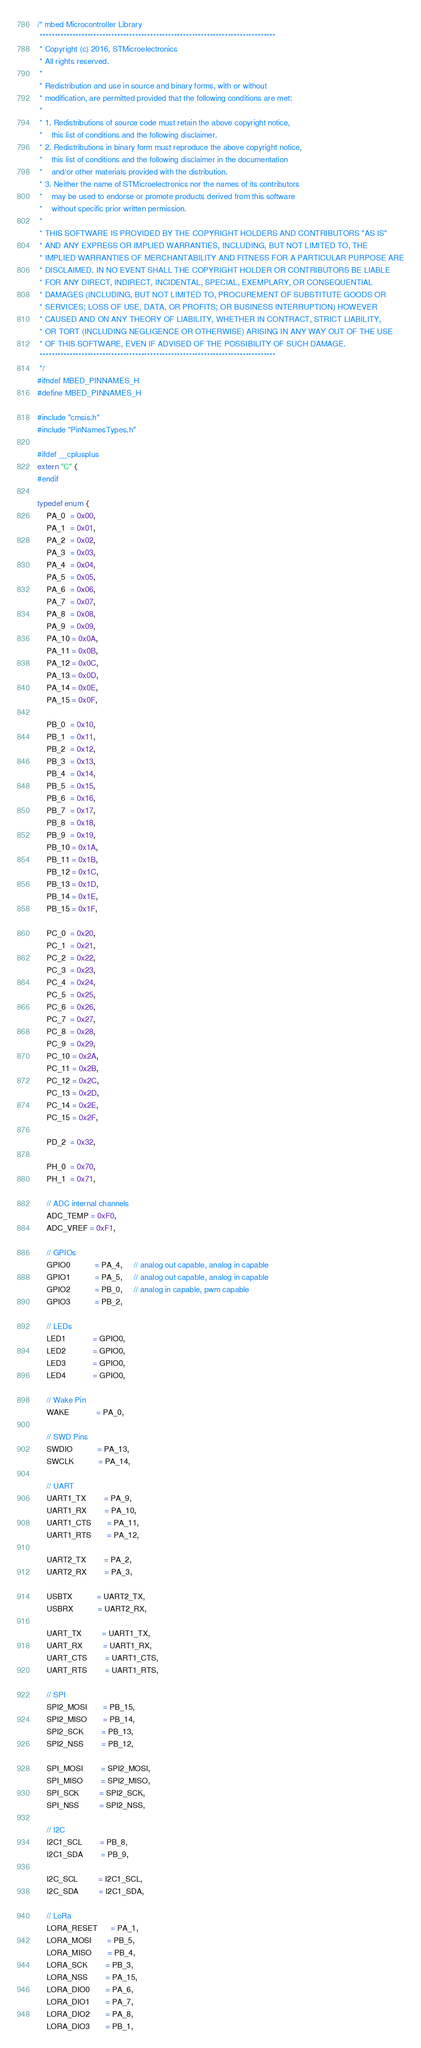<code> <loc_0><loc_0><loc_500><loc_500><_C_>/* mbed Microcontroller Library
 *******************************************************************************
 * Copyright (c) 2016, STMicroelectronics
 * All rights reserved.
 *
 * Redistribution and use in source and binary forms, with or without
 * modification, are permitted provided that the following conditions are met:
 *
 * 1. Redistributions of source code must retain the above copyright notice,
 *    this list of conditions and the following disclaimer.
 * 2. Redistributions in binary form must reproduce the above copyright notice,
 *    this list of conditions and the following disclaimer in the documentation
 *    and/or other materials provided with the distribution.
 * 3. Neither the name of STMicroelectronics nor the names of its contributors
 *    may be used to endorse or promote products derived from this software
 *    without specific prior written permission.
 *
 * THIS SOFTWARE IS PROVIDED BY THE COPYRIGHT HOLDERS AND CONTRIBUTORS "AS IS"
 * AND ANY EXPRESS OR IMPLIED WARRANTIES, INCLUDING, BUT NOT LIMITED TO, THE
 * IMPLIED WARRANTIES OF MERCHANTABILITY AND FITNESS FOR A PARTICULAR PURPOSE ARE
 * DISCLAIMED. IN NO EVENT SHALL THE COPYRIGHT HOLDER OR CONTRIBUTORS BE LIABLE
 * FOR ANY DIRECT, INDIRECT, INCIDENTAL, SPECIAL, EXEMPLARY, OR CONSEQUENTIAL
 * DAMAGES (INCLUDING, BUT NOT LIMITED TO, PROCUREMENT OF SUBSTITUTE GOODS OR
 * SERVICES; LOSS OF USE, DATA, OR PROFITS; OR BUSINESS INTERRUPTION) HOWEVER
 * CAUSED AND ON ANY THEORY OF LIABILITY, WHETHER IN CONTRACT, STRICT LIABILITY,
 * OR TORT (INCLUDING NEGLIGENCE OR OTHERWISE) ARISING IN ANY WAY OUT OF THE USE
 * OF THIS SOFTWARE, EVEN IF ADVISED OF THE POSSIBILITY OF SUCH DAMAGE.
 *******************************************************************************
 */
#ifndef MBED_PINNAMES_H
#define MBED_PINNAMES_H

#include "cmsis.h"
#include "PinNamesTypes.h"

#ifdef __cplusplus
extern "C" {
#endif

typedef enum {
    PA_0  = 0x00,
    PA_1  = 0x01,
    PA_2  = 0x02,
    PA_3  = 0x03,
    PA_4  = 0x04,
    PA_5  = 0x05,
    PA_6  = 0x06,
    PA_7  = 0x07,
    PA_8  = 0x08,
    PA_9  = 0x09,
    PA_10 = 0x0A,
    PA_11 = 0x0B,
    PA_12 = 0x0C,
    PA_13 = 0x0D,
    PA_14 = 0x0E,
    PA_15 = 0x0F,

    PB_0  = 0x10,
    PB_1  = 0x11,
    PB_2  = 0x12,
    PB_3  = 0x13,
    PB_4  = 0x14,
    PB_5  = 0x15,
    PB_6  = 0x16,
    PB_7  = 0x17,
    PB_8  = 0x18,
    PB_9  = 0x19,
    PB_10 = 0x1A,
    PB_11 = 0x1B,
    PB_12 = 0x1C,
    PB_13 = 0x1D,
    PB_14 = 0x1E,
    PB_15 = 0x1F,

    PC_0  = 0x20,
    PC_1  = 0x21,
    PC_2  = 0x22,
    PC_3  = 0x23,
    PC_4  = 0x24,
    PC_5  = 0x25,
    PC_6  = 0x26,
    PC_7  = 0x27,
    PC_8  = 0x28,
    PC_9  = 0x29,
    PC_10 = 0x2A,
    PC_11 = 0x2B,
    PC_12 = 0x2C,
    PC_13 = 0x2D,
    PC_14 = 0x2E,
    PC_15 = 0x2F,

    PD_2  = 0x32,

    PH_0  = 0x70,
    PH_1  = 0x71,

    // ADC internal channels
    ADC_TEMP = 0xF0,
    ADC_VREF = 0xF1,

    // GPIOs
    GPIO0           = PA_4,     // analog out capable, analog in capable
    GPIO1           = PA_5,     // analog out capable, analog in capable
    GPIO2           = PB_0,     // analog in capable, pwm capable
    GPIO3           = PB_2,

    // LEDs
    LED1            = GPIO0,
    LED2            = GPIO0,
    LED3            = GPIO0,
    LED4            = GPIO0,

    // Wake Pin
    WAKE            = PA_0,

    // SWD Pins
    SWDIO           = PA_13,
    SWCLK           = PA_14,

    // UART
    UART1_TX        = PA_9,
    UART1_RX        = PA_10,
    UART1_CTS       = PA_11,
    UART1_RTS       = PA_12,

    UART2_TX        = PA_2,
    UART2_RX        = PA_3,

    USBTX           = UART2_TX,
    USBRX           = UART2_RX,

    UART_TX         = UART1_TX,
    UART_RX         = UART1_RX,
    UART_CTS        = UART1_CTS,
    UART_RTS        = UART1_RTS,

    // SPI
    SPI2_MOSI       = PB_15,
    SPI2_MISO       = PB_14,
    SPI2_SCK        = PB_13,
    SPI2_NSS        = PB_12,

    SPI_MOSI        = SPI2_MOSI,
    SPI_MISO        = SPI2_MISO,
    SPI_SCK         = SPI2_SCK,
    SPI_NSS         = SPI2_NSS,

    // I2C
    I2C1_SCL        = PB_8,
    I2C1_SDA        = PB_9,

    I2C_SCL         = I2C1_SCL,
    I2C_SDA         = I2C1_SDA,

    // LoRa
    LORA_RESET      = PA_1,
    LORA_MOSI       = PB_5,
    LORA_MISO       = PB_4,
    LORA_SCK        = PB_3,
    LORA_NSS        = PA_15,
    LORA_DIO0       = PA_6,
    LORA_DIO1       = PA_7,
    LORA_DIO2       = PA_8,
    LORA_DIO3       = PB_1,</code> 